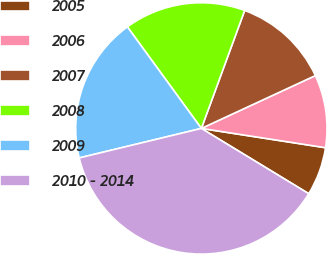<chart> <loc_0><loc_0><loc_500><loc_500><pie_chart><fcel>2005<fcel>2006<fcel>2007<fcel>2008<fcel>2009<fcel>2010 - 2014<nl><fcel>6.24%<fcel>9.36%<fcel>12.49%<fcel>15.62%<fcel>18.75%<fcel>37.53%<nl></chart> 